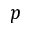Convert formula to latex. <formula><loc_0><loc_0><loc_500><loc_500>p</formula> 